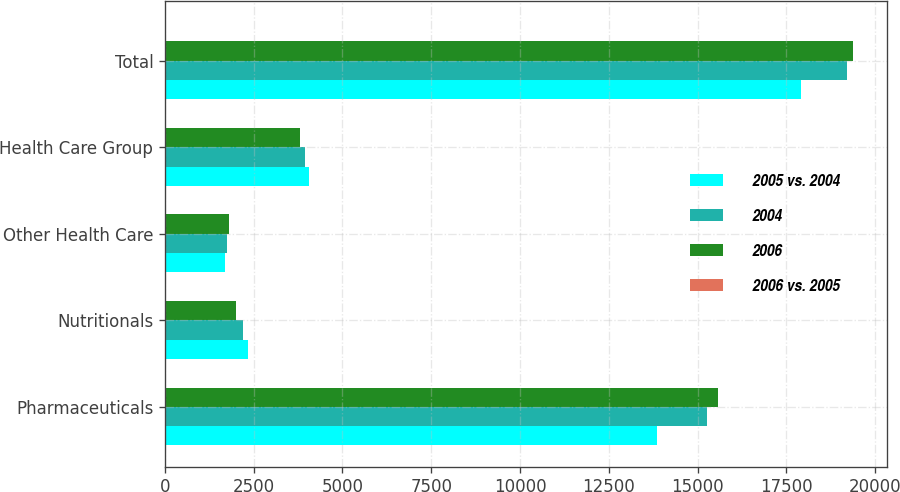<chart> <loc_0><loc_0><loc_500><loc_500><stacked_bar_chart><ecel><fcel>Pharmaceuticals<fcel>Nutritionals<fcel>Other Health Care<fcel>Health Care Group<fcel>Total<nl><fcel>2005 vs. 2004<fcel>13861<fcel>2347<fcel>1706<fcel>4053<fcel>17914<nl><fcel>2004<fcel>15254<fcel>2205<fcel>1748<fcel>3953<fcel>19207<nl><fcel>2006<fcel>15564<fcel>2001<fcel>1815<fcel>3816<fcel>19380<nl><fcel>2006 vs. 2005<fcel>9<fcel>6<fcel>2<fcel>3<fcel>7<nl></chart> 